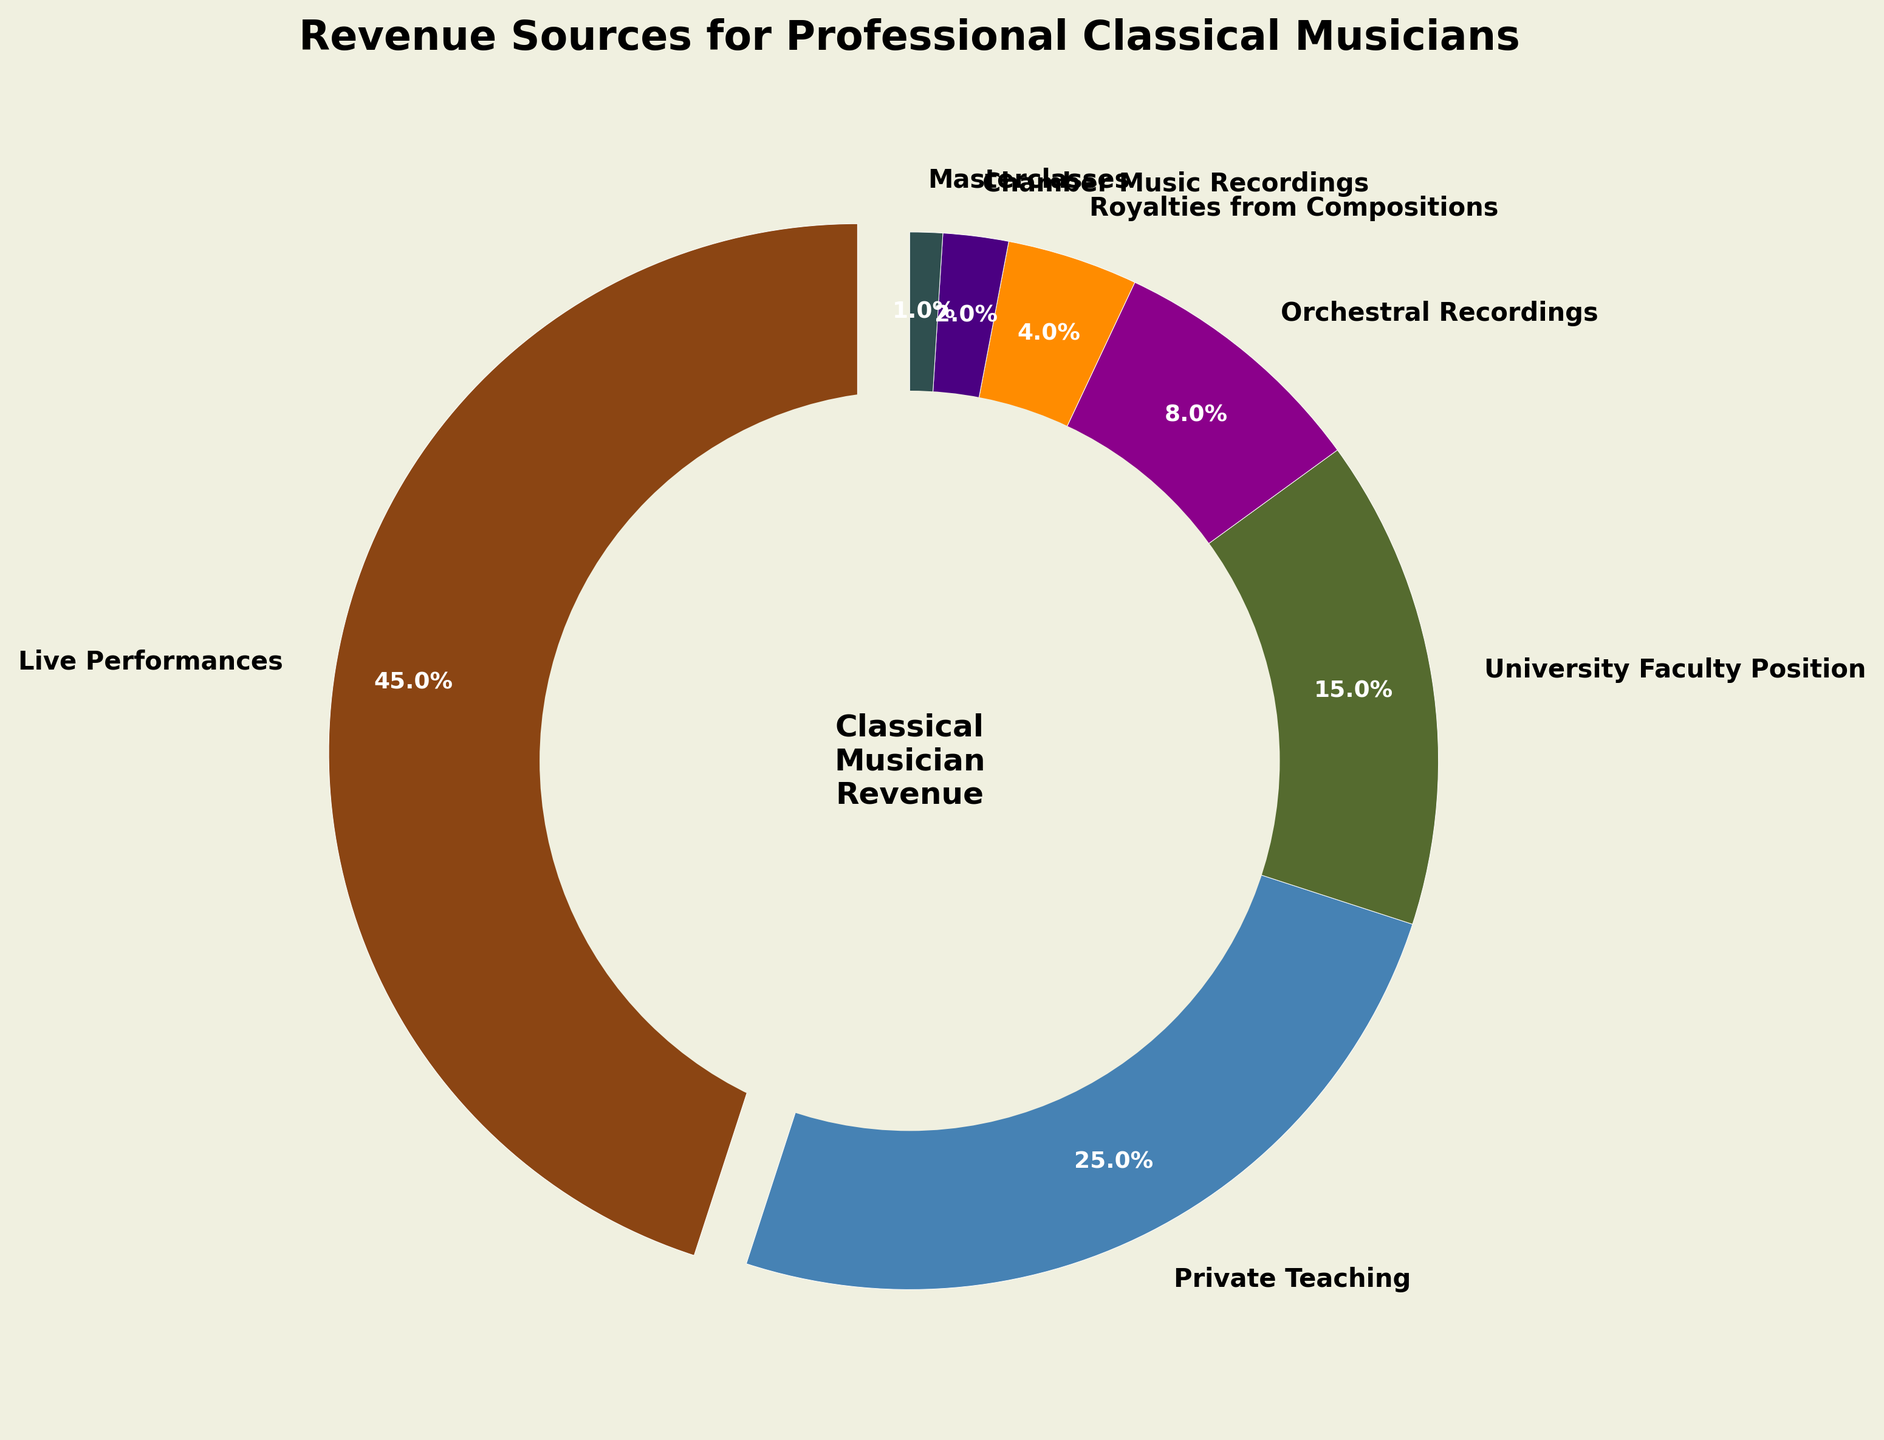What percentage of revenue comes from live performances and teaching combined? Firstly, identify the percentages of "Live Performances" and "Private Teaching", which are 45% and 25% respectively. Sum them up: 45% + 25% = 70%.
Answer: 70% Which revenue source contributes less, royalties from compositions or chamber music recordings? Compare the given percentages of "Royalties from Compositions" and "Chamber Music Recordings". The former is 4% and the latter is 2%. Since 2% is less than 4%, "Chamber Music Recordings" contributes less.
Answer: Chamber Music Recordings What is the difference in revenue percentage between university faculty positions and private teaching? Identify the percentages of "University Faculty Position" and "Private Teaching", which are 15% and 25% respectively. Calculate the difference: 25% - 15% = 10%.
Answer: 10% How much more revenue do live performances generate compared to orchestral recordings? Identify the percentages of "Live Performances" and "Orchestral Recordings", which are 45% and 8% respectively. Calculate the difference: 45% - 8% = 37%.
Answer: 37% What percentage of revenue is generated by activities other than live performances? Identify the percentage of "Live Performances", which is 45%. Other activities account for the remaining percentage. Subtract 45% from 100%: 100% - 45% = 55%.
Answer: 55% If you combine university faculty positions and orchestral recordings, does their combined revenue percentage exceed private teaching? Identify the percentages of "University Faculty Position", "Orchestral Recordings", and "Private Teaching", which are 15%, 8%, and 25% respectively. Combine the first two: 15% + 8% = 23%. Compare this with 25%. Since 23% is not greater than 25%, their combined percentage does not exceed private teaching.
Answer: No Which revenue source, among orchestral recordings, chamber music recordings, and masterclasses, generates the least revenue? Compare the percentages of "Orchestral Recordings" (8%), "Chamber Music Recordings" (2%), and "Masterclasses" (1%). The smallest percentage among these is 1%, so "Masterclasses" generate the least revenue.
Answer: Masterclasses What is the average revenue percentage of royalties from compositions and masterclasses? Identify the percentages of "Royalties from Compositions" and "Masterclasses", which are 4% and 1% respectively. Calculate their sum and divide by 2: (4% + 1%) / 2 = 2.5%.
Answer: 2.5% What is the ratio of revenue from live performances to university faculty positions? Identify the percentages of "Live Performances" and "University Faculty Position", which are 45% and 15% respectively. Divide the former by the latter: 45% / 15% = 3. The ratio is 3:1.
Answer: 3:1 